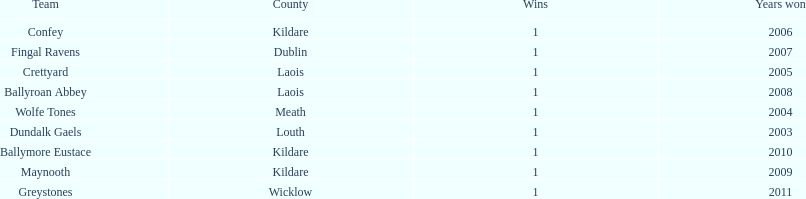Which county had the most number of wins? Kildare. 